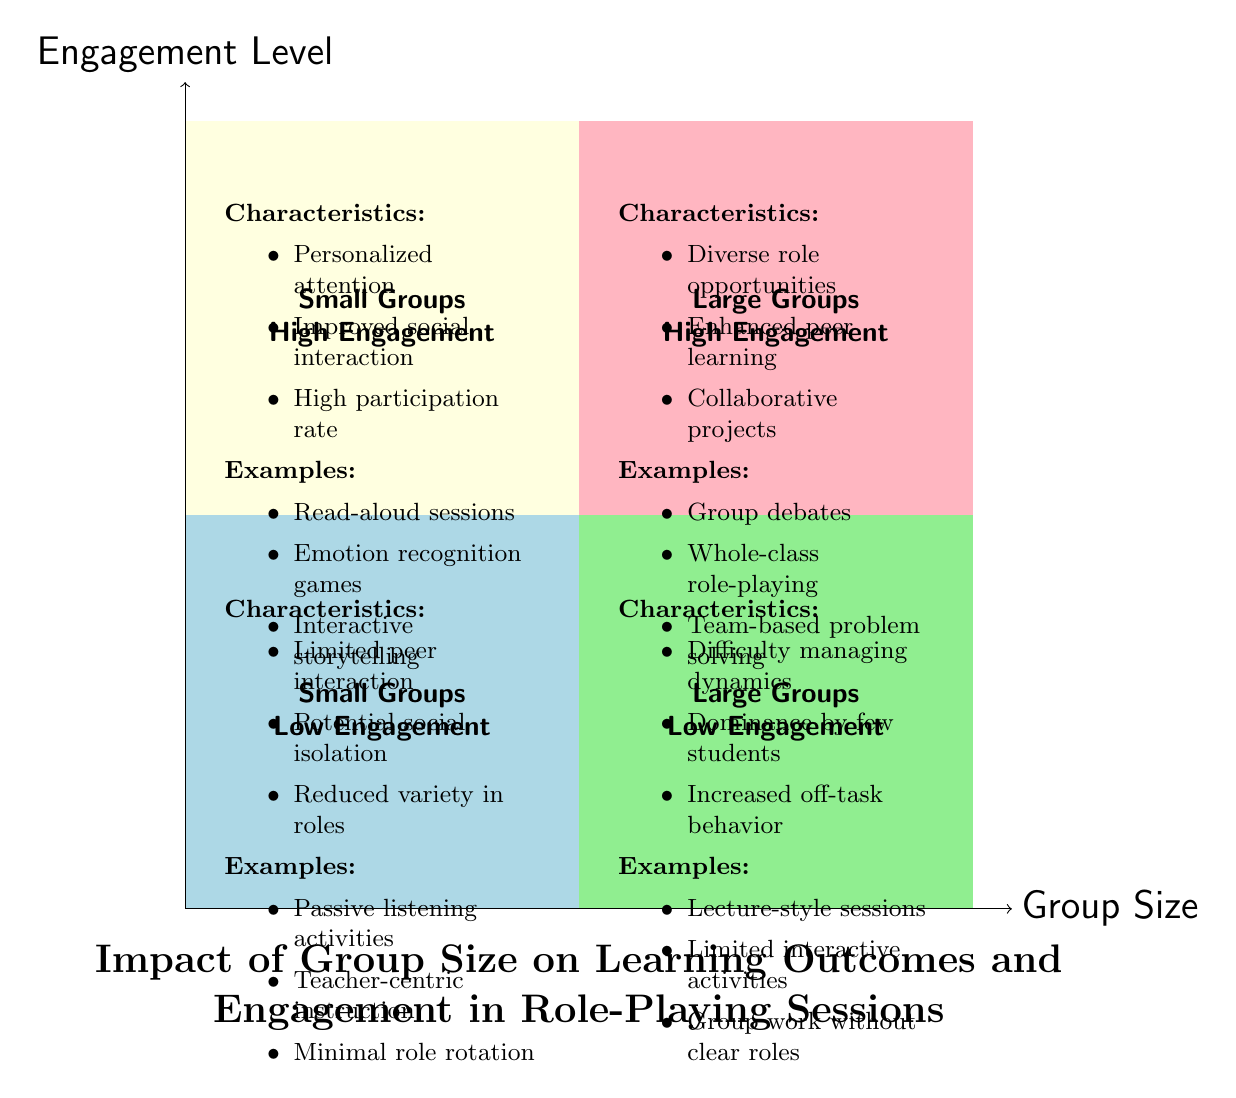What type of engagement level is associated with small groups? The diagram shows that small groups have two engagement levels: high and low. The quadrant labeled "Small Groups High Engagement" specifically indicates that it is associated with high engagement.
Answer: high engagement What are the characteristics of large groups with low engagement? Referring to the "Large Groups Low Engagement" quadrant, the listed characteristics include difficulty managing group dynamics, dominance by few students, and increased risk of off-task behavior.
Answer: difficulty managing dynamics, dominance by few students, increased off-task behavior How many types of engagement levels are defined in the diagram? The diagram divides the engagement levels into two categories: high and low. It illustrates these across both small and large groups, resulting in a total of four quadrants.
Answer: two Which quadrant includes collaborative projects? Collaborative projects are mentioned in the "Large Groups High Engagement" quadrant as one of its characteristics.
Answer: Large Groups High Engagement What is an example of an activity listed in the "Small Groups High Engagement" quadrant? The diagram illustrates several examples for the "Small Groups High Engagement" quadrant, one of which is "Emotion recognition games."
Answer: Emotion recognition games What is the maximum group size indicated in the diagram? The maximum group size specified in the diagram is 12 students, present in the "Large Groups" quadrants.
Answer: 12 students Which quadrant has "Passive listening activities" as an example? "Passive listening activities" are found in the "Small Groups Low Engagement" quadrant, as indicated by the provided examples.
Answer: Small Groups Low Engagement What type of activities is highlighted in the "Large Groups High Engagement" quadrant? This quadrant highlights activities that promote interaction and learning, specifically mentioning group debates, whole-class role-playing scenarios, and team-based problem solving.
Answer: group debates and discussions What is a common risk identified in large groups with low engagement? The diagram identifies "increased risk of off-task behavior" as a common risk in the "Large Groups Low Engagement" quadrant.
Answer: increased risk of off-task behavior 